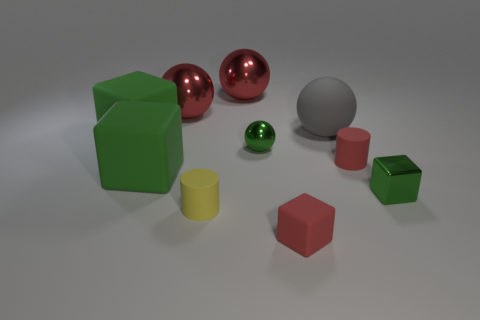Subtract all red blocks. How many blocks are left? 3 Subtract all purple spheres. How many green blocks are left? 3 Subtract 2 balls. How many balls are left? 2 Subtract all red blocks. How many blocks are left? 3 Subtract all yellow cubes. Subtract all green cylinders. How many cubes are left? 4 Subtract all rubber blocks. Subtract all tiny shiny objects. How many objects are left? 5 Add 2 red cylinders. How many red cylinders are left? 3 Add 6 big green matte blocks. How many big green matte blocks exist? 8 Subtract 0 blue blocks. How many objects are left? 10 Subtract all cubes. How many objects are left? 6 